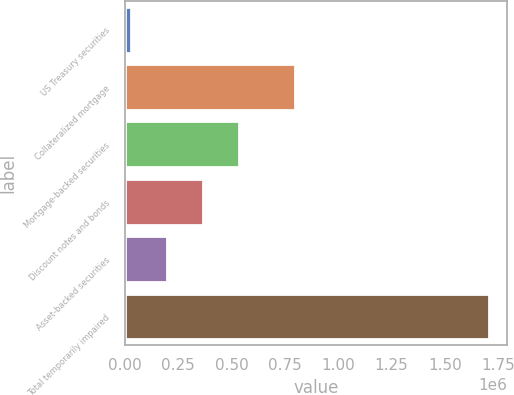Convert chart. <chart><loc_0><loc_0><loc_500><loc_500><bar_chart><fcel>US Treasury securities<fcel>Collateralized mortgage<fcel>Mortgage-backed securities<fcel>Discount notes and bonds<fcel>Asset-backed securities<fcel>Total temporarily impaired<nl><fcel>29700<fcel>799377<fcel>533113<fcel>365308<fcel>197504<fcel>1.70774e+06<nl></chart> 